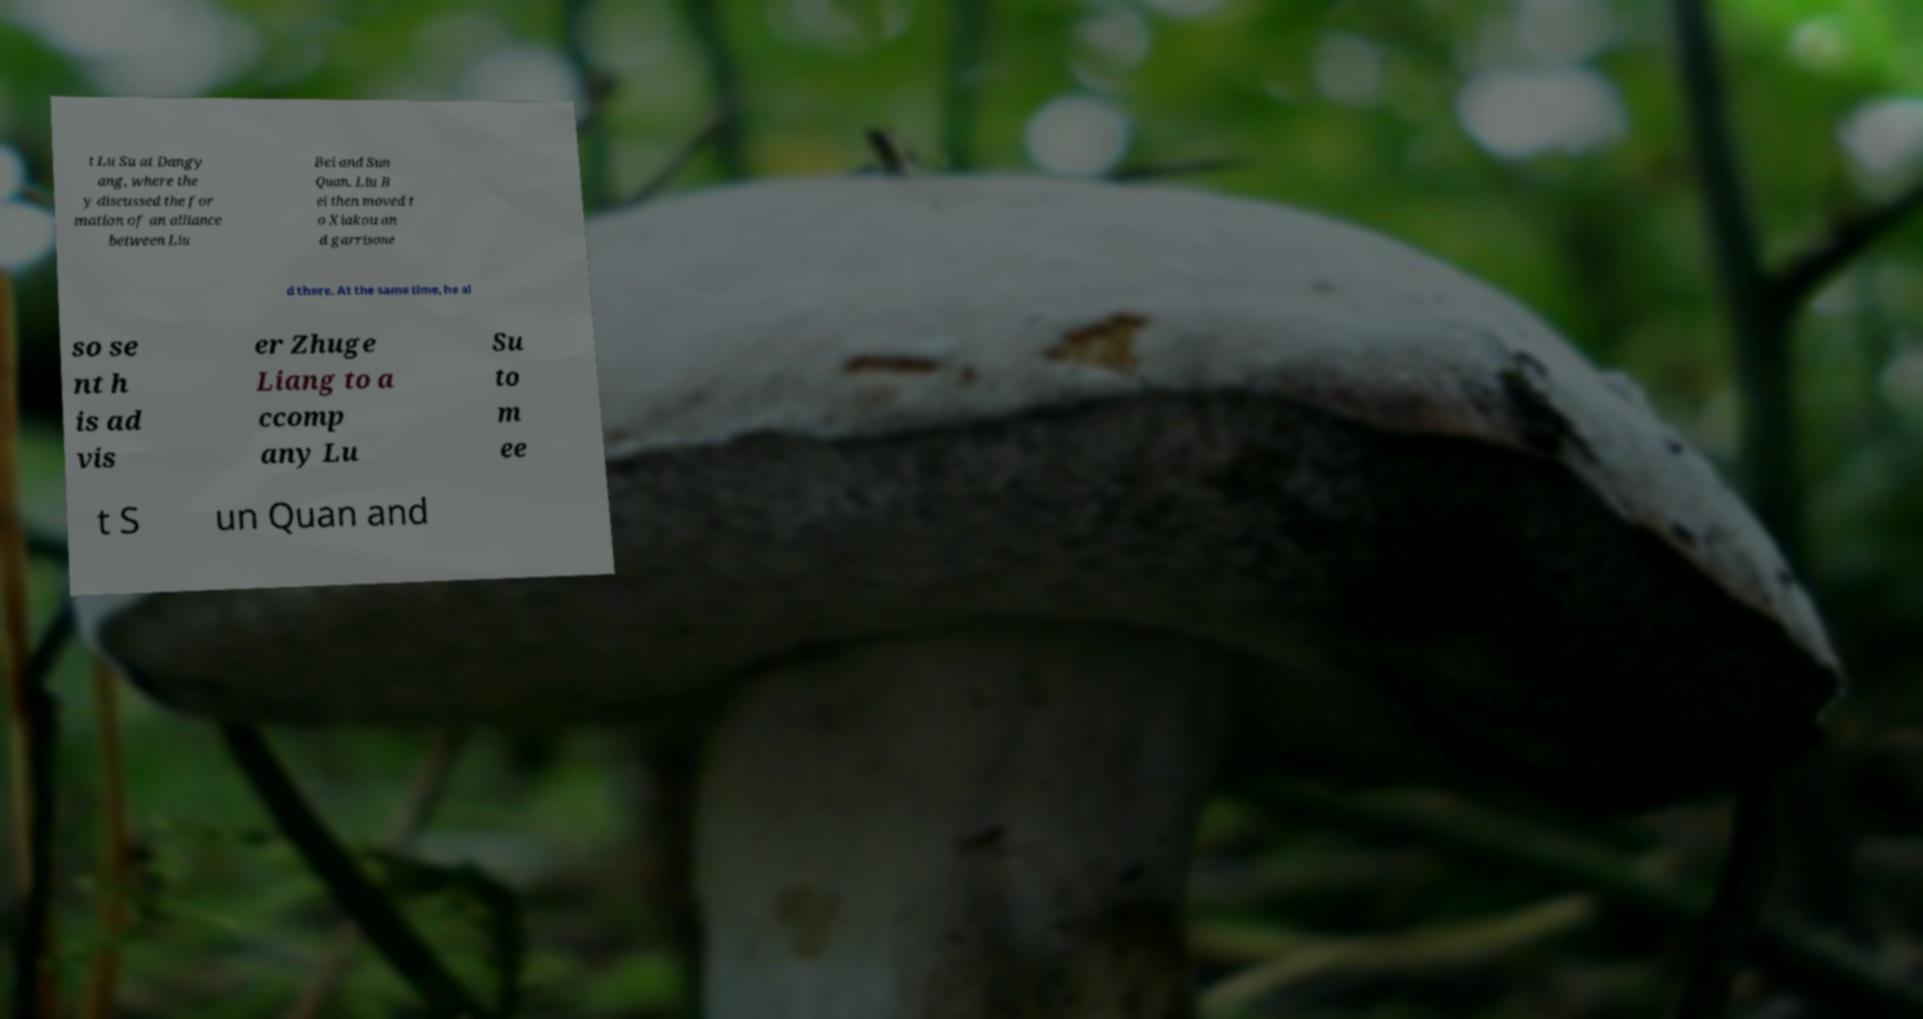Could you assist in decoding the text presented in this image and type it out clearly? t Lu Su at Dangy ang, where the y discussed the for mation of an alliance between Liu Bei and Sun Quan. Liu B ei then moved t o Xiakou an d garrisone d there. At the same time, he al so se nt h is ad vis er Zhuge Liang to a ccomp any Lu Su to m ee t S un Quan and 